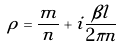Convert formula to latex. <formula><loc_0><loc_0><loc_500><loc_500>\rho = \frac { m } { n } + i \frac { \beta l } { 2 \pi n }</formula> 